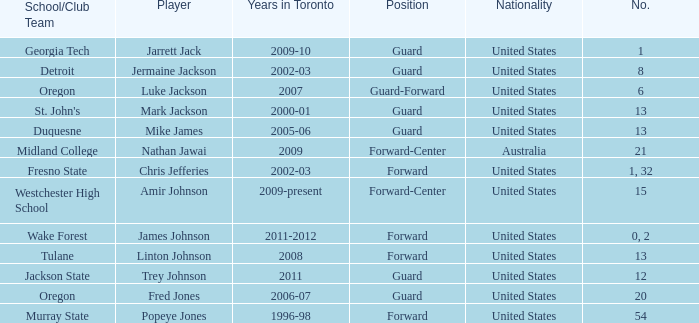Who are all of the players on the Westchester High School club team? Amir Johnson. 